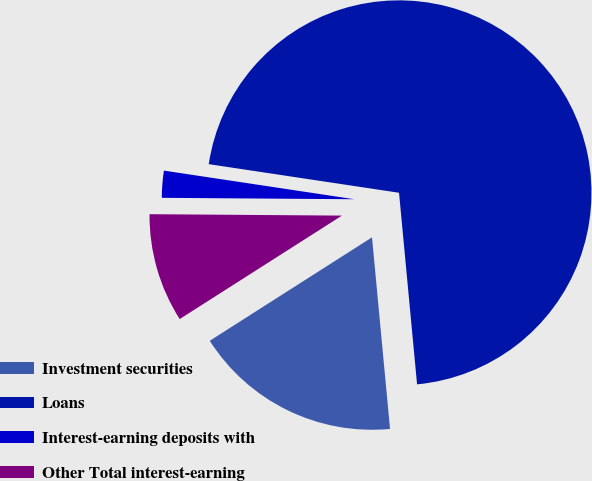Convert chart. <chart><loc_0><loc_0><loc_500><loc_500><pie_chart><fcel>Investment securities<fcel>Loans<fcel>Interest-earning deposits with<fcel>Other Total interest-earning<nl><fcel>17.46%<fcel>71.13%<fcel>2.26%<fcel>9.15%<nl></chart> 